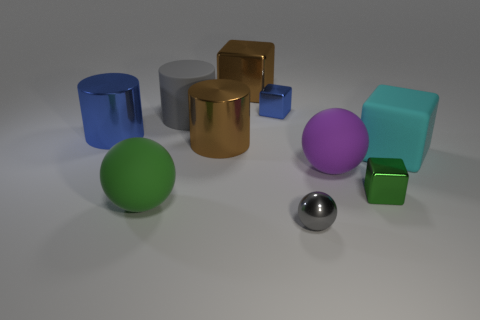Subtract 1 blocks. How many blocks are left? 3 Subtract all balls. How many objects are left? 7 Subtract 1 purple spheres. How many objects are left? 9 Subtract all gray rubber objects. Subtract all large purple matte objects. How many objects are left? 8 Add 1 cyan objects. How many cyan objects are left? 2 Add 4 small red rubber things. How many small red rubber things exist? 4 